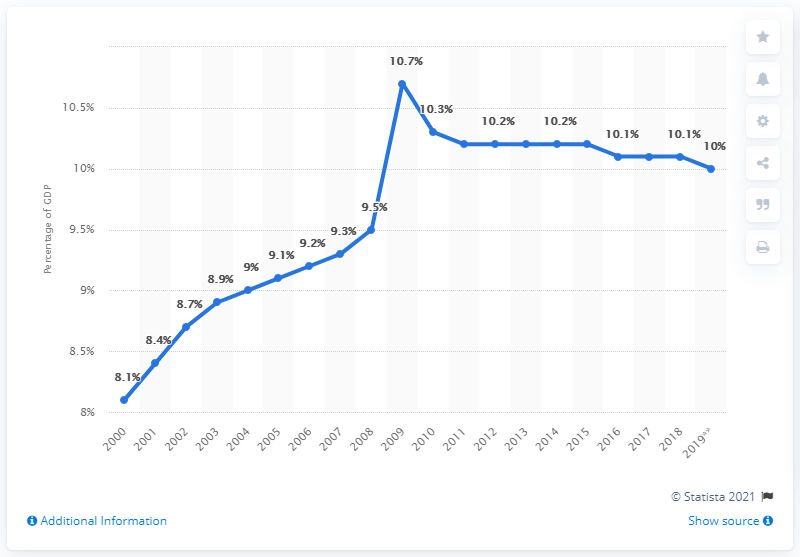Point out several critical features in this image. The total health care expenditure in Denmark reached its peak in 2009. In 2009, health care expenditure in Denmark accounted for 10.7% of the country's Gross Domestic Product (GDP). Health care expenditure in Denmark was estimated to be approximately 10% of the country's total expenditure in 2019. 